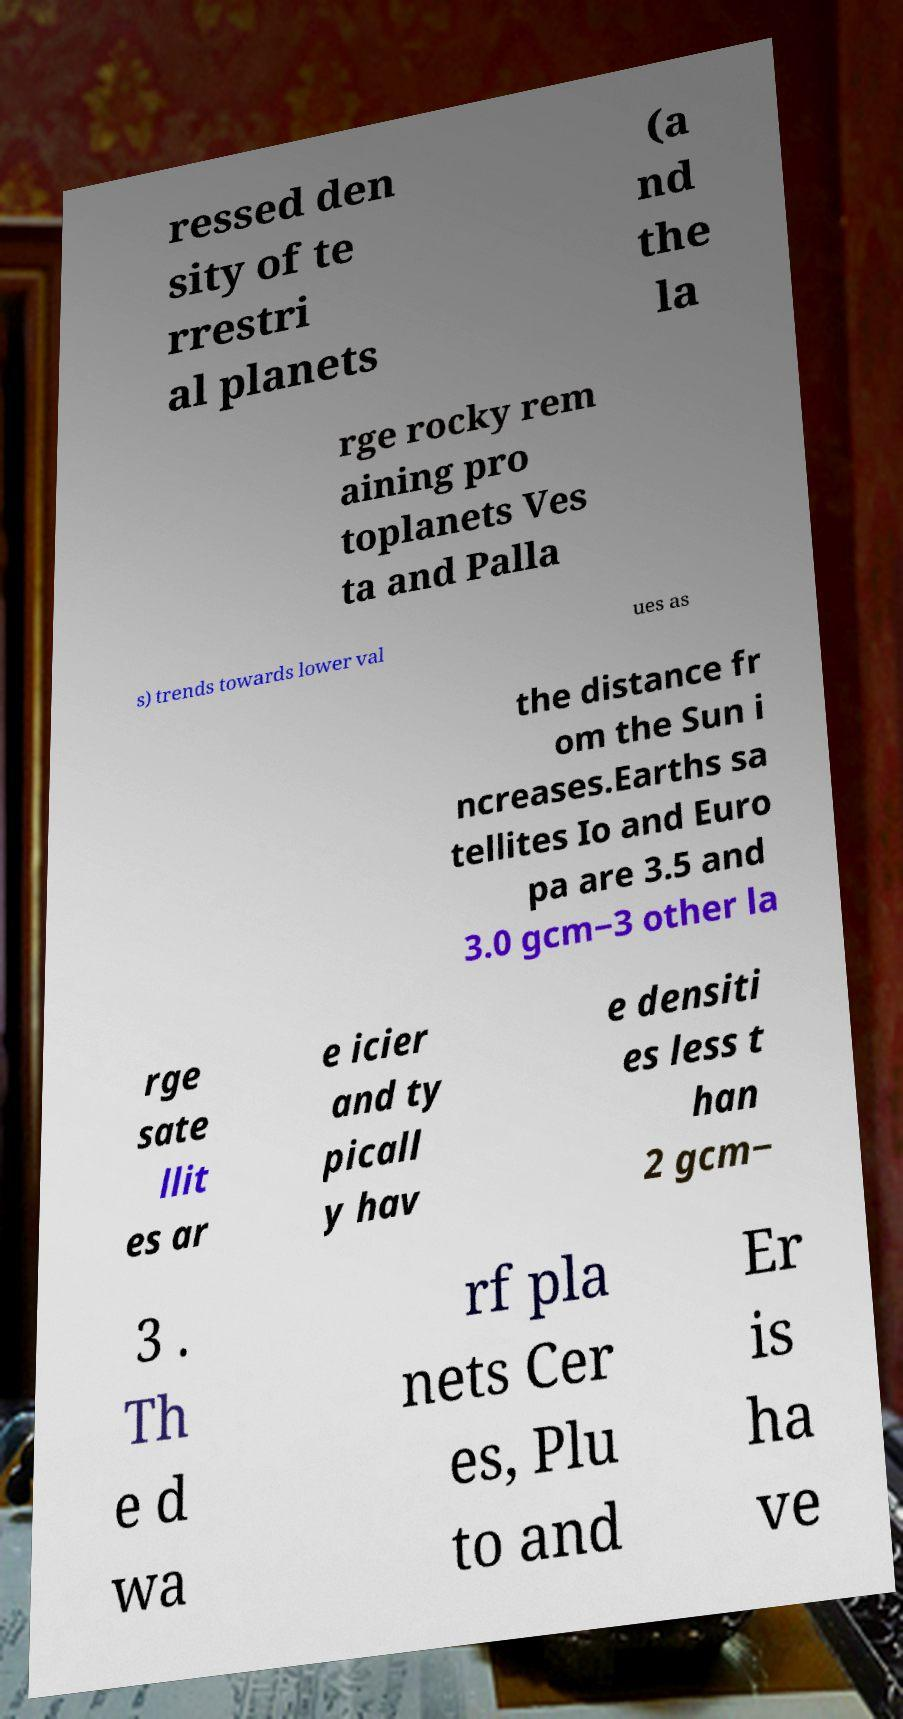Could you assist in decoding the text presented in this image and type it out clearly? ressed den sity of te rrestri al planets (a nd the la rge rocky rem aining pro toplanets Ves ta and Palla s) trends towards lower val ues as the distance fr om the Sun i ncreases.Earths sa tellites Io and Euro pa are 3.5 and 3.0 gcm−3 other la rge sate llit es ar e icier and ty picall y hav e densiti es less t han 2 gcm− 3 . Th e d wa rf pla nets Cer es, Plu to and Er is ha ve 